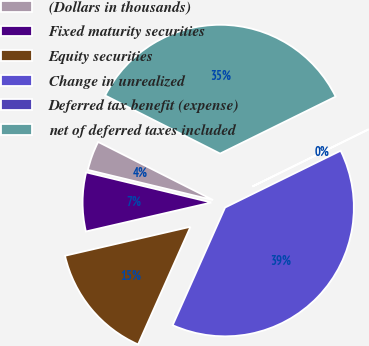Convert chart to OTSL. <chart><loc_0><loc_0><loc_500><loc_500><pie_chart><fcel>(Dollars in thousands)<fcel>Fixed maturity securities<fcel>Equity securities<fcel>Change in unrealized<fcel>Deferred tax benefit (expense)<fcel>net of deferred taxes included<nl><fcel>3.69%<fcel>7.37%<fcel>14.72%<fcel>38.94%<fcel>0.02%<fcel>35.26%<nl></chart> 